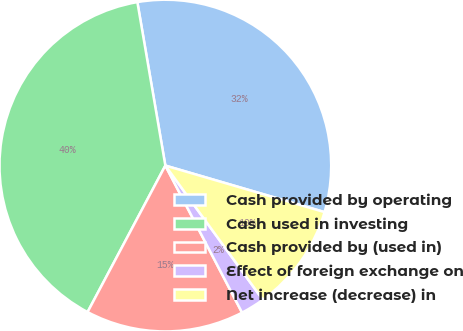Convert chart. <chart><loc_0><loc_0><loc_500><loc_500><pie_chart><fcel>Cash provided by operating<fcel>Cash used in investing<fcel>Cash provided by (used in)<fcel>Effect of foreign exchange on<fcel>Net increase (decrease) in<nl><fcel>32.22%<fcel>39.53%<fcel>15.42%<fcel>2.35%<fcel>10.47%<nl></chart> 